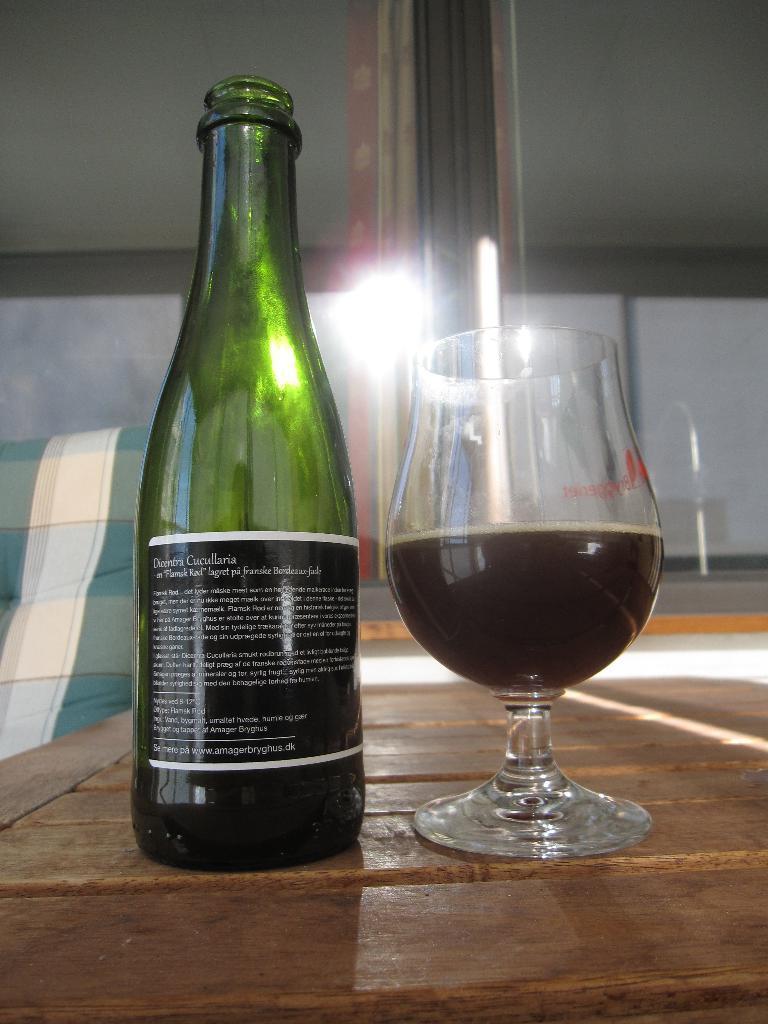In one or two sentences, can you explain what this image depicts? This picture shows a wine bottle and a wine glass on the table 